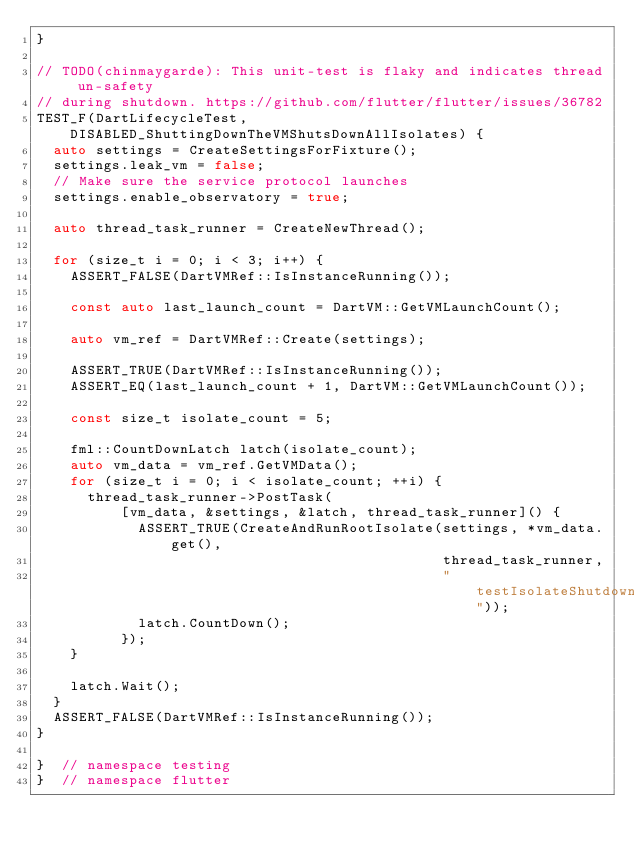Convert code to text. <code><loc_0><loc_0><loc_500><loc_500><_C++_>}

// TODO(chinmaygarde): This unit-test is flaky and indicates thread un-safety
// during shutdown. https://github.com/flutter/flutter/issues/36782
TEST_F(DartLifecycleTest, DISABLED_ShuttingDownTheVMShutsDownAllIsolates) {
  auto settings = CreateSettingsForFixture();
  settings.leak_vm = false;
  // Make sure the service protocol launches
  settings.enable_observatory = true;

  auto thread_task_runner = CreateNewThread();

  for (size_t i = 0; i < 3; i++) {
    ASSERT_FALSE(DartVMRef::IsInstanceRunning());

    const auto last_launch_count = DartVM::GetVMLaunchCount();

    auto vm_ref = DartVMRef::Create(settings);

    ASSERT_TRUE(DartVMRef::IsInstanceRunning());
    ASSERT_EQ(last_launch_count + 1, DartVM::GetVMLaunchCount());

    const size_t isolate_count = 5;

    fml::CountDownLatch latch(isolate_count);
    auto vm_data = vm_ref.GetVMData();
    for (size_t i = 0; i < isolate_count; ++i) {
      thread_task_runner->PostTask(
          [vm_data, &settings, &latch, thread_task_runner]() {
            ASSERT_TRUE(CreateAndRunRootIsolate(settings, *vm_data.get(),
                                                thread_task_runner,
                                                "testIsolateShutdown"));
            latch.CountDown();
          });
    }

    latch.Wait();
  }
  ASSERT_FALSE(DartVMRef::IsInstanceRunning());
}

}  // namespace testing
}  // namespace flutter
</code> 